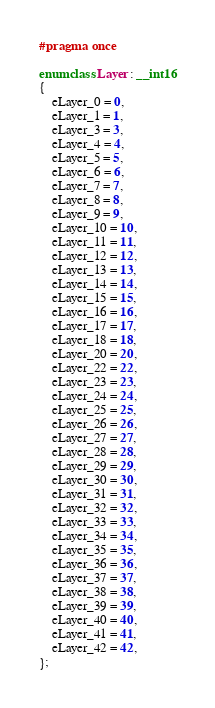<code> <loc_0><loc_0><loc_500><loc_500><_C++_>#pragma once

enum class Layer : __int16
{
    eLayer_0 = 0,
    eLayer_1 = 1,
    eLayer_3 = 3,
    eLayer_4 = 4,
    eLayer_5 = 5,
    eLayer_6 = 6,
    eLayer_7 = 7,
    eLayer_8 = 8,
    eLayer_9 = 9,
    eLayer_10 = 10,
    eLayer_11 = 11,
    eLayer_12 = 12,
    eLayer_13 = 13,
    eLayer_14 = 14,
    eLayer_15 = 15,
    eLayer_16 = 16,
    eLayer_17 = 17,
    eLayer_18 = 18,
    eLayer_20 = 20,
    eLayer_22 = 22,
    eLayer_23 = 23,
    eLayer_24 = 24,
    eLayer_25 = 25,
    eLayer_26 = 26,
    eLayer_27 = 27,
    eLayer_28 = 28,
    eLayer_29 = 29,
    eLayer_30 = 30,
    eLayer_31 = 31,
    eLayer_32 = 32,
    eLayer_33 = 33,
    eLayer_34 = 34,
    eLayer_35 = 35,
    eLayer_36 = 36,
    eLayer_37 = 37,
    eLayer_38 = 38,
    eLayer_39 = 39,
    eLayer_40 = 40,
    eLayer_41 = 41,
    eLayer_42 = 42,
};
</code> 